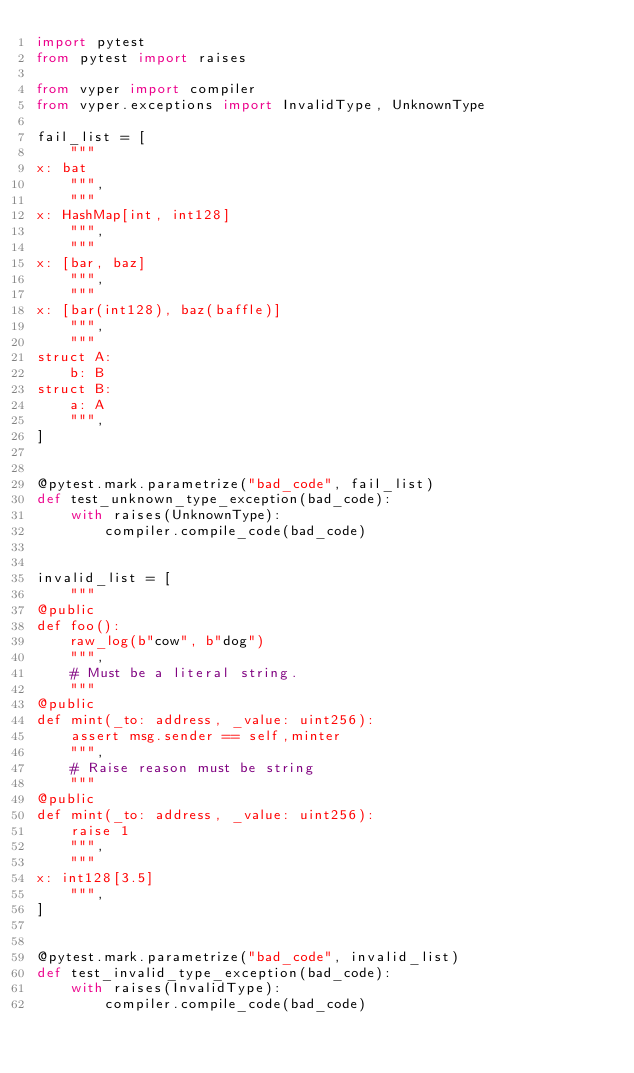<code> <loc_0><loc_0><loc_500><loc_500><_Python_>import pytest
from pytest import raises

from vyper import compiler
from vyper.exceptions import InvalidType, UnknownType

fail_list = [
    """
x: bat
    """,
    """
x: HashMap[int, int128]
    """,
    """
x: [bar, baz]
    """,
    """
x: [bar(int128), baz(baffle)]
    """,
    """
struct A:
    b: B
struct B:
    a: A
    """,
]


@pytest.mark.parametrize("bad_code", fail_list)
def test_unknown_type_exception(bad_code):
    with raises(UnknownType):
        compiler.compile_code(bad_code)


invalid_list = [
    """
@public
def foo():
    raw_log(b"cow", b"dog")
    """,
    # Must be a literal string.
    """
@public
def mint(_to: address, _value: uint256):
    assert msg.sender == self,minter
    """,
    # Raise reason must be string
    """
@public
def mint(_to: address, _value: uint256):
    raise 1
    """,
    """
x: int128[3.5]
    """,
]


@pytest.mark.parametrize("bad_code", invalid_list)
def test_invalid_type_exception(bad_code):
    with raises(InvalidType):
        compiler.compile_code(bad_code)
</code> 